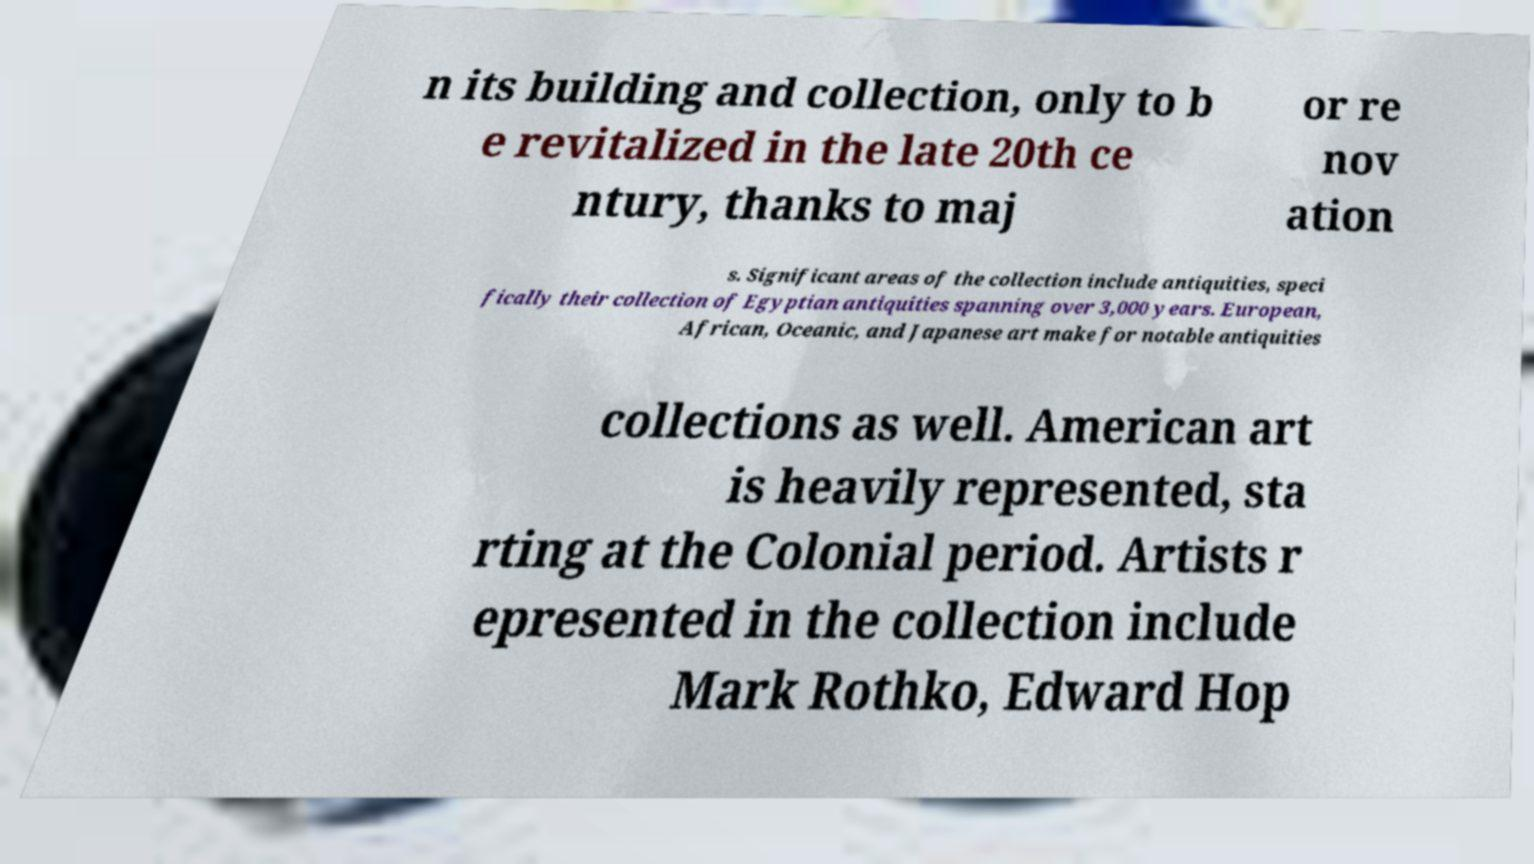Please identify and transcribe the text found in this image. n its building and collection, only to b e revitalized in the late 20th ce ntury, thanks to maj or re nov ation s. Significant areas of the collection include antiquities, speci fically their collection of Egyptian antiquities spanning over 3,000 years. European, African, Oceanic, and Japanese art make for notable antiquities collections as well. American art is heavily represented, sta rting at the Colonial period. Artists r epresented in the collection include Mark Rothko, Edward Hop 